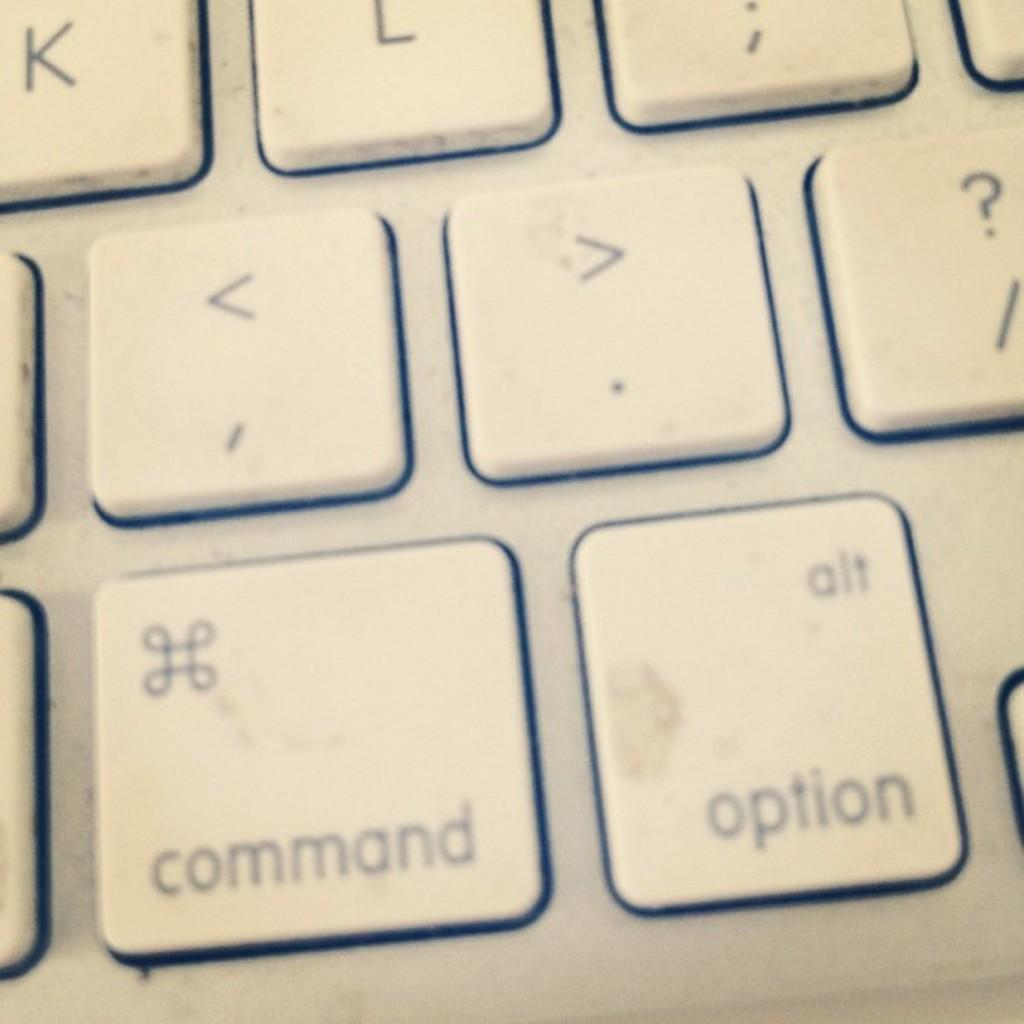In one or two sentences, can you explain what this image depicts? In this zoomed picture there are keys of a laptop. There are symbols and text on the keys. 